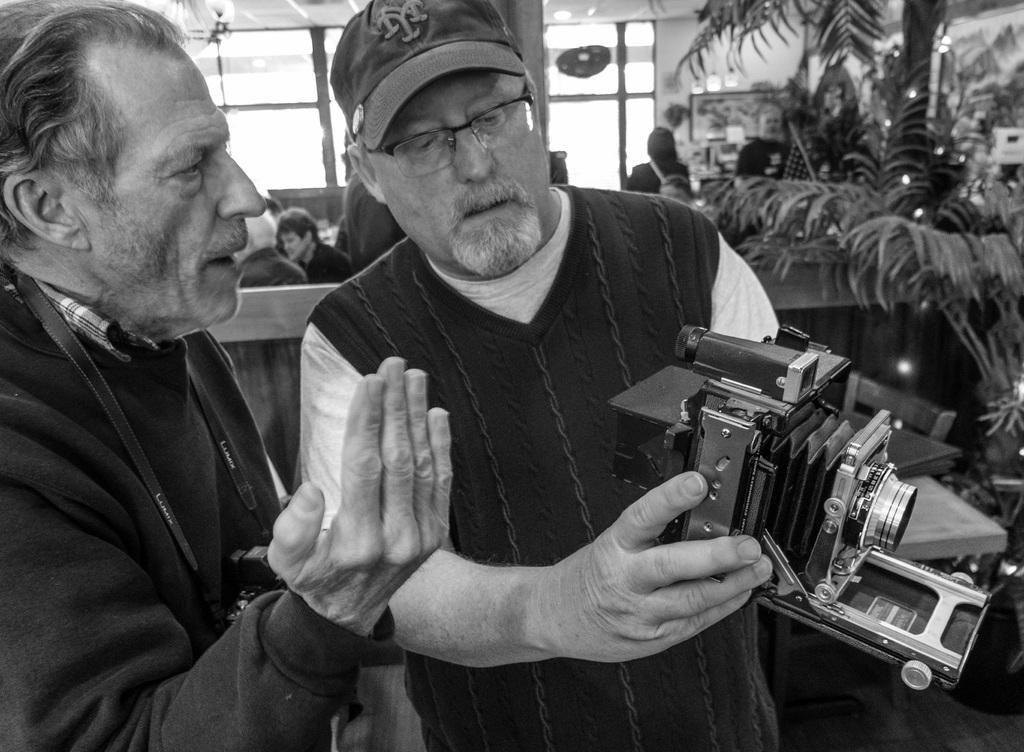How many old persons are in the image? There are two old persons standing in the image. What is one of the old persons holding? One of the old persons is holding a camera in his hands. Can you describe the background of the image? In the background, there are three persons visible, and there is a glass window. What type of sweater is the old person wearing? There is no mention of a sweater in the image. --- Facts: 1. There is a person sitting on a chair. 2. The person is holding a book. 3. The book is titled "The Art of War" by Sun Tzu. 4. The chair is made of wood. 5. The person is wearing glasses. Absurd Topics: elephant, piano, ice cream Conversation: What is the person in the image doing? The person in the image is sitting on a chair and holding a book. What is the title of the book the person is holding? The title of the book is "The Art of War" by Sun Tzu. What is the chair made of? The chair is made of wood. What is the person wearing while reading the book? The person is wearing glasses. Reasoning: Let's think step by step in order to produce the conversation. We start by identifying the main subject in the image, which is the person sitting on a chair. Then, we describe what the person is doing, which is holding a book. Next, we provide the title of the book the person is holding. After that, we describe the material of the chair, which is made of wood. Finally, we mention what the person is wearing while reading the book, which are glasses. Absurd Question/Answer: Can you hear the elephant playing the piano in the image? There is no mention of an elephant, a piano, or ice cream in the image. 